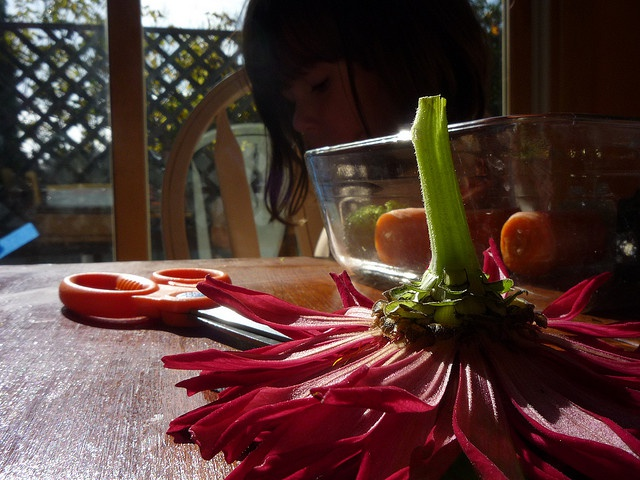Describe the objects in this image and their specific colors. I can see people in black, maroon, and gray tones, chair in black, maroon, and gray tones, and scissors in black, maroon, and white tones in this image. 